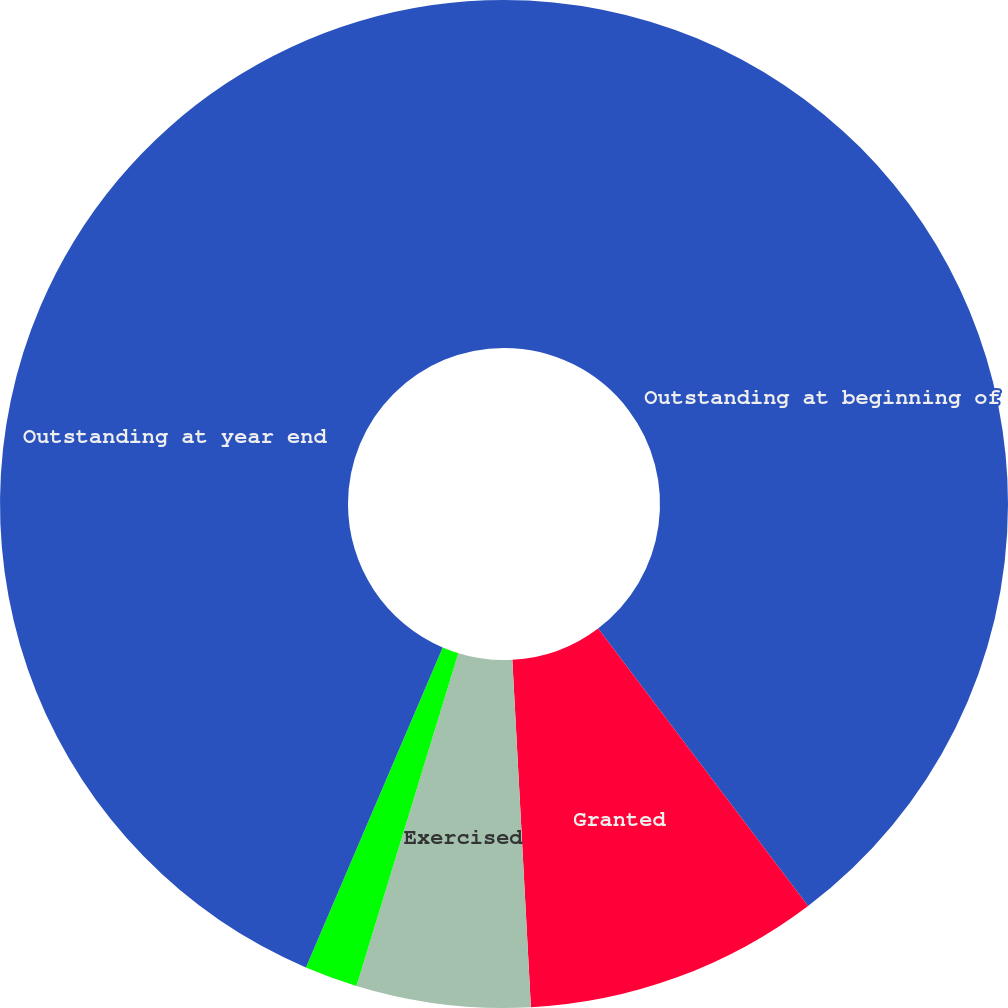Convert chart to OTSL. <chart><loc_0><loc_0><loc_500><loc_500><pie_chart><fcel>Outstanding at beginning of<fcel>Granted<fcel>Exercised<fcel>Canceled<fcel>Outstanding at year end<nl><fcel>39.7%<fcel>9.46%<fcel>5.58%<fcel>1.7%<fcel>43.58%<nl></chart> 